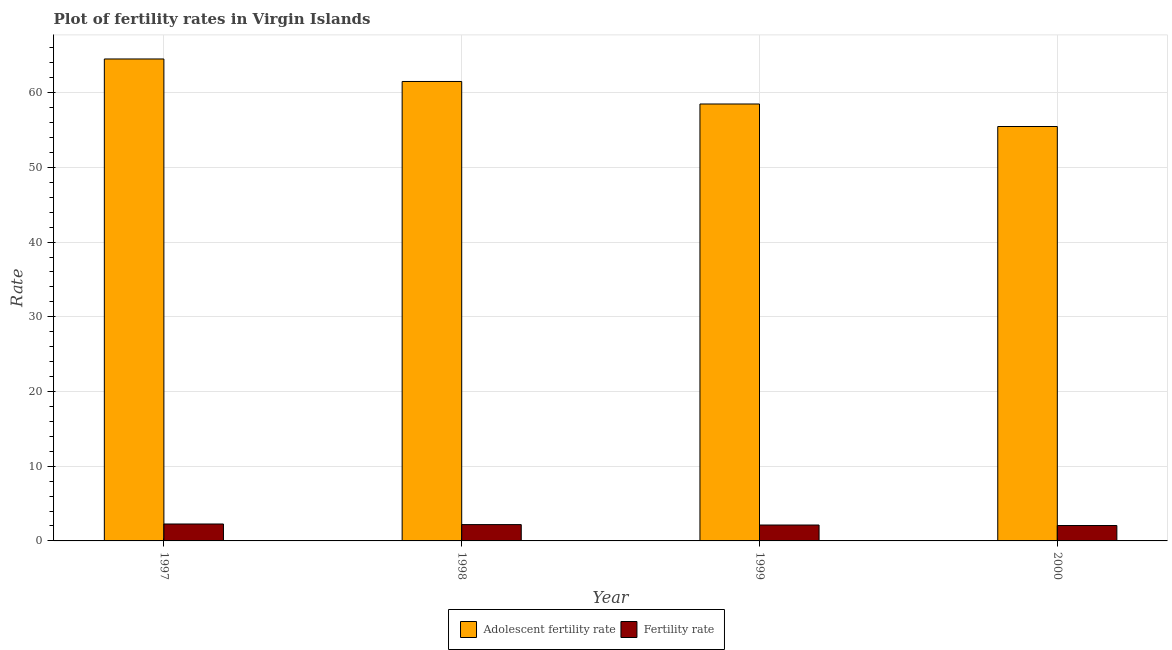How many different coloured bars are there?
Provide a short and direct response. 2. How many groups of bars are there?
Your response must be concise. 4. Are the number of bars on each tick of the X-axis equal?
Offer a very short reply. Yes. How many bars are there on the 1st tick from the right?
Keep it short and to the point. 2. In how many cases, is the number of bars for a given year not equal to the number of legend labels?
Give a very brief answer. 0. What is the adolescent fertility rate in 1998?
Keep it short and to the point. 61.5. Across all years, what is the maximum adolescent fertility rate?
Offer a very short reply. 64.51. Across all years, what is the minimum adolescent fertility rate?
Make the answer very short. 55.47. In which year was the adolescent fertility rate maximum?
Your answer should be very brief. 1997. In which year was the fertility rate minimum?
Offer a very short reply. 2000. What is the total adolescent fertility rate in the graph?
Provide a short and direct response. 239.96. What is the difference between the fertility rate in 1998 and that in 1999?
Offer a terse response. 0.06. What is the difference between the adolescent fertility rate in 1998 and the fertility rate in 1999?
Keep it short and to the point. 3.01. What is the average adolescent fertility rate per year?
Your answer should be compact. 59.99. In the year 2000, what is the difference between the fertility rate and adolescent fertility rate?
Your answer should be compact. 0. What is the ratio of the fertility rate in 1997 to that in 2000?
Provide a succinct answer. 1.1. Is the adolescent fertility rate in 1997 less than that in 1999?
Offer a terse response. No. What is the difference between the highest and the second highest fertility rate?
Offer a terse response. 0.08. What is the difference between the highest and the lowest fertility rate?
Keep it short and to the point. 0.21. What does the 1st bar from the left in 2000 represents?
Give a very brief answer. Adolescent fertility rate. What does the 2nd bar from the right in 1997 represents?
Provide a short and direct response. Adolescent fertility rate. How many bars are there?
Your response must be concise. 8. How many years are there in the graph?
Make the answer very short. 4. What is the difference between two consecutive major ticks on the Y-axis?
Keep it short and to the point. 10. Are the values on the major ticks of Y-axis written in scientific E-notation?
Your response must be concise. No. Where does the legend appear in the graph?
Offer a very short reply. Bottom center. How many legend labels are there?
Your answer should be very brief. 2. What is the title of the graph?
Provide a short and direct response. Plot of fertility rates in Virgin Islands. Does "Grants" appear as one of the legend labels in the graph?
Your answer should be compact. No. What is the label or title of the X-axis?
Provide a succinct answer. Year. What is the label or title of the Y-axis?
Provide a short and direct response. Rate. What is the Rate in Adolescent fertility rate in 1997?
Provide a short and direct response. 64.51. What is the Rate of Fertility rate in 1997?
Ensure brevity in your answer.  2.27. What is the Rate of Adolescent fertility rate in 1998?
Your answer should be very brief. 61.5. What is the Rate in Fertility rate in 1998?
Make the answer very short. 2.18. What is the Rate in Adolescent fertility rate in 1999?
Your response must be concise. 58.48. What is the Rate in Fertility rate in 1999?
Your response must be concise. 2.13. What is the Rate of Adolescent fertility rate in 2000?
Ensure brevity in your answer.  55.47. What is the Rate in Fertility rate in 2000?
Provide a short and direct response. 2.06. Across all years, what is the maximum Rate of Adolescent fertility rate?
Give a very brief answer. 64.51. Across all years, what is the maximum Rate of Fertility rate?
Keep it short and to the point. 2.27. Across all years, what is the minimum Rate of Adolescent fertility rate?
Keep it short and to the point. 55.47. Across all years, what is the minimum Rate of Fertility rate?
Provide a succinct answer. 2.06. What is the total Rate in Adolescent fertility rate in the graph?
Provide a succinct answer. 239.96. What is the total Rate in Fertility rate in the graph?
Make the answer very short. 8.64. What is the difference between the Rate in Adolescent fertility rate in 1997 and that in 1998?
Provide a succinct answer. 3.01. What is the difference between the Rate in Fertility rate in 1997 and that in 1998?
Provide a short and direct response. 0.08. What is the difference between the Rate of Adolescent fertility rate in 1997 and that in 1999?
Provide a succinct answer. 6.03. What is the difference between the Rate in Fertility rate in 1997 and that in 1999?
Offer a very short reply. 0.14. What is the difference between the Rate of Adolescent fertility rate in 1997 and that in 2000?
Keep it short and to the point. 9.04. What is the difference between the Rate of Fertility rate in 1997 and that in 2000?
Make the answer very short. 0.2. What is the difference between the Rate of Adolescent fertility rate in 1998 and that in 1999?
Provide a short and direct response. 3.01. What is the difference between the Rate of Fertility rate in 1998 and that in 1999?
Offer a very short reply. 0.06. What is the difference between the Rate in Adolescent fertility rate in 1998 and that in 2000?
Your response must be concise. 6.03. What is the difference between the Rate of Fertility rate in 1998 and that in 2000?
Your answer should be very brief. 0.12. What is the difference between the Rate in Adolescent fertility rate in 1999 and that in 2000?
Your response must be concise. 3.01. What is the difference between the Rate in Fertility rate in 1999 and that in 2000?
Give a very brief answer. 0.07. What is the difference between the Rate of Adolescent fertility rate in 1997 and the Rate of Fertility rate in 1998?
Provide a short and direct response. 62.33. What is the difference between the Rate in Adolescent fertility rate in 1997 and the Rate in Fertility rate in 1999?
Ensure brevity in your answer.  62.38. What is the difference between the Rate of Adolescent fertility rate in 1997 and the Rate of Fertility rate in 2000?
Your response must be concise. 62.45. What is the difference between the Rate of Adolescent fertility rate in 1998 and the Rate of Fertility rate in 1999?
Offer a terse response. 59.37. What is the difference between the Rate in Adolescent fertility rate in 1998 and the Rate in Fertility rate in 2000?
Make the answer very short. 59.44. What is the difference between the Rate in Adolescent fertility rate in 1999 and the Rate in Fertility rate in 2000?
Your response must be concise. 56.42. What is the average Rate in Adolescent fertility rate per year?
Provide a short and direct response. 59.99. What is the average Rate in Fertility rate per year?
Provide a short and direct response. 2.16. In the year 1997, what is the difference between the Rate of Adolescent fertility rate and Rate of Fertility rate?
Give a very brief answer. 62.24. In the year 1998, what is the difference between the Rate of Adolescent fertility rate and Rate of Fertility rate?
Provide a succinct answer. 59.31. In the year 1999, what is the difference between the Rate of Adolescent fertility rate and Rate of Fertility rate?
Offer a terse response. 56.35. In the year 2000, what is the difference between the Rate of Adolescent fertility rate and Rate of Fertility rate?
Your response must be concise. 53.41. What is the ratio of the Rate of Adolescent fertility rate in 1997 to that in 1998?
Provide a succinct answer. 1.05. What is the ratio of the Rate of Fertility rate in 1997 to that in 1998?
Your response must be concise. 1.04. What is the ratio of the Rate of Adolescent fertility rate in 1997 to that in 1999?
Your answer should be compact. 1.1. What is the ratio of the Rate of Fertility rate in 1997 to that in 1999?
Offer a very short reply. 1.06. What is the ratio of the Rate of Adolescent fertility rate in 1997 to that in 2000?
Your response must be concise. 1.16. What is the ratio of the Rate in Fertility rate in 1997 to that in 2000?
Offer a terse response. 1.1. What is the ratio of the Rate of Adolescent fertility rate in 1998 to that in 1999?
Keep it short and to the point. 1.05. What is the ratio of the Rate of Fertility rate in 1998 to that in 1999?
Provide a succinct answer. 1.03. What is the ratio of the Rate in Adolescent fertility rate in 1998 to that in 2000?
Keep it short and to the point. 1.11. What is the ratio of the Rate of Fertility rate in 1998 to that in 2000?
Keep it short and to the point. 1.06. What is the ratio of the Rate in Adolescent fertility rate in 1999 to that in 2000?
Keep it short and to the point. 1.05. What is the ratio of the Rate of Fertility rate in 1999 to that in 2000?
Keep it short and to the point. 1.03. What is the difference between the highest and the second highest Rate in Adolescent fertility rate?
Provide a succinct answer. 3.01. What is the difference between the highest and the second highest Rate in Fertility rate?
Provide a succinct answer. 0.08. What is the difference between the highest and the lowest Rate in Adolescent fertility rate?
Keep it short and to the point. 9.04. What is the difference between the highest and the lowest Rate in Fertility rate?
Give a very brief answer. 0.2. 